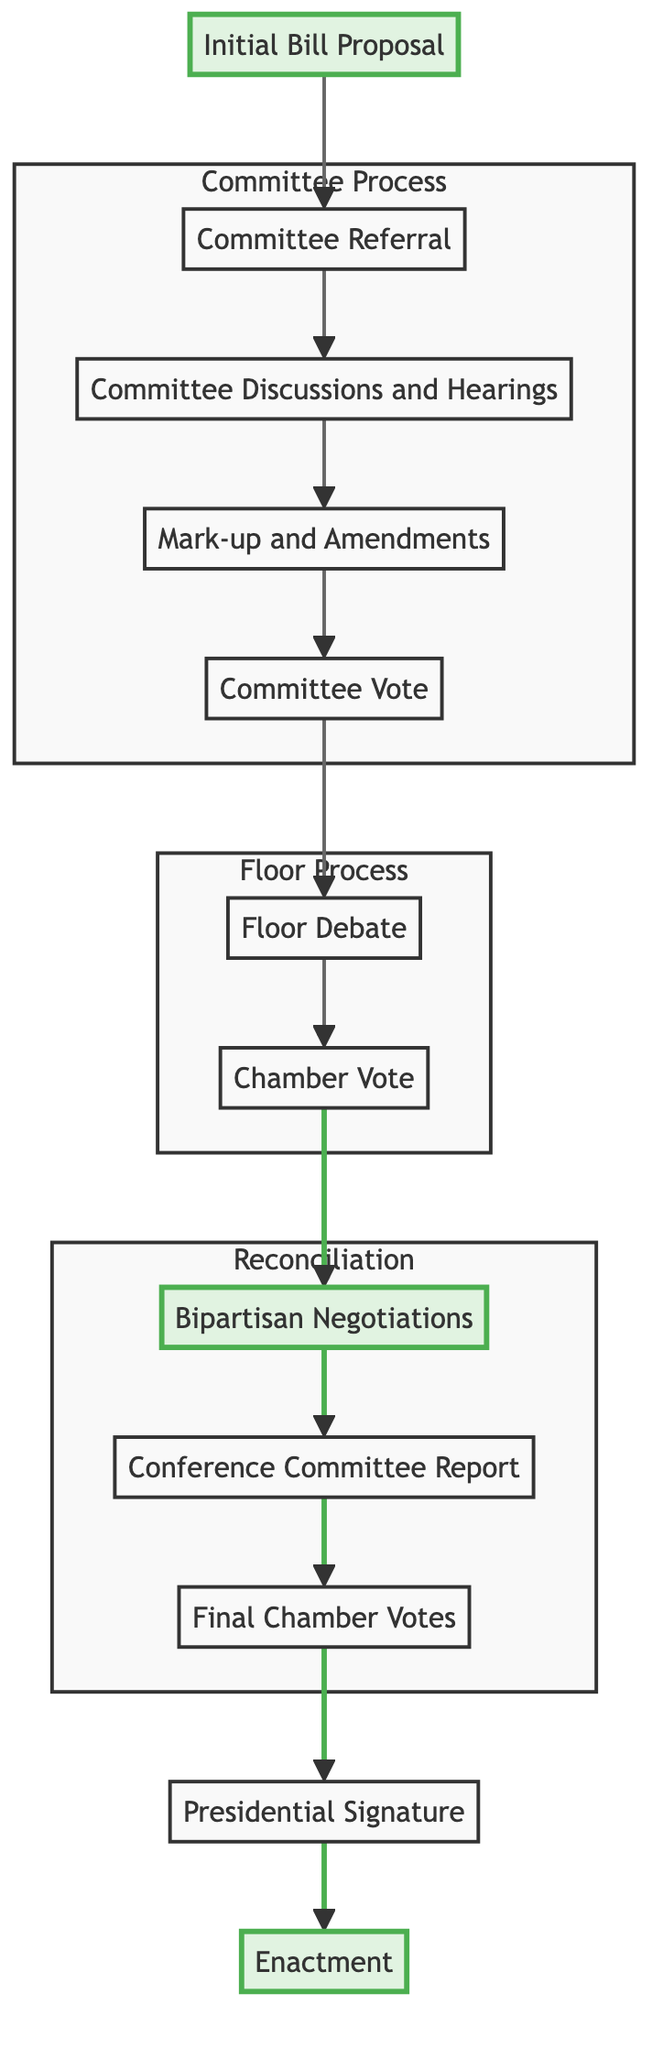What is the first step in the bipartisan legislative process? The flow chart indicates that the first step is "Initial Bill Proposal," where a bill is introduced by a senator or representative.
Answer: Initial Bill Proposal How many steps are there in total from the initial bill proposal to enactment? The flow chart outlines 12 distinct steps from "Initial Bill Proposal" to "Enactment," including all processes like committee discussions and presidential signature.
Answer: 12 What is the role of the conference committee in this process? The "Bipartisan Negotiations" step indicates that the conference committee reconciles differences between versions of the bill from both houses.
Answer: Reconcile differences Which two key persons are involved in bipartisan negotiations? The "Bipartisan Negotiations" step lists "Key Senators" and "Key Representatives" as the involved parties, with examples being Senator Joe Manchin and Representative Elissa Slotkin.
Answer: Key Senators and Key Representatives What step follows after the chamber vote? The flow chart shows that after the "Chamber Vote," the next step is "Bipartisan Negotiations," where differences between chambers are addressed.
Answer: Bipartisan Negotiations What happens after the final chamber votes? According to the chart, once both chambers have voted on the final version of the bill, it moves to the "Presidential Signature" step for the President's approval.
Answer: Presidential Signature How do committee members contribute to the bill's progress? The "Mark-up and Amendments" step describes how committee members propose changes and amendments, allowing for refinement before the committee vote.
Answer: Propose changes What is required for a bill to proceed to the full chamber for a vote? The "Committee Vote" step indicates that the committee must vote in favor of sending the bill to the full chamber for consideration.
Answer: Committee must vote in favor What is the final outcome of the process depicted in this flowchart? The last step, "Enactment," states that after the presidential signature, the bill officially becomes law.
Answer: Becomes law 